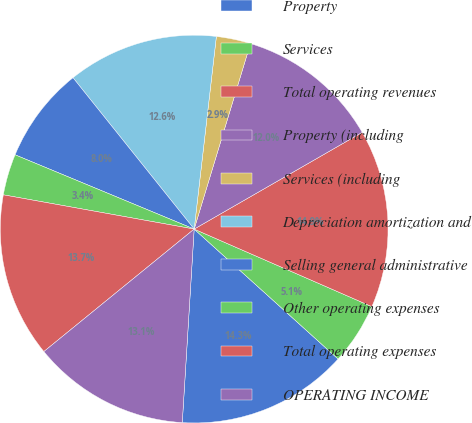<chart> <loc_0><loc_0><loc_500><loc_500><pie_chart><fcel>Property<fcel>Services<fcel>Total operating revenues<fcel>Property (including<fcel>Services (including<fcel>Depreciation amortization and<fcel>Selling general administrative<fcel>Other operating expenses<fcel>Total operating expenses<fcel>OPERATING INCOME<nl><fcel>14.29%<fcel>5.14%<fcel>14.86%<fcel>12.0%<fcel>2.86%<fcel>12.57%<fcel>8.0%<fcel>3.43%<fcel>13.71%<fcel>13.14%<nl></chart> 